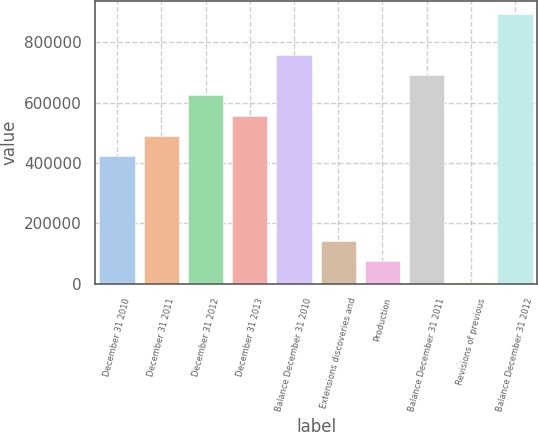<chart> <loc_0><loc_0><loc_500><loc_500><bar_chart><fcel>December 31 2010<fcel>December 31 2011<fcel>December 31 2012<fcel>December 31 2013<fcel>Balance December 31 2010<fcel>Extensions discoveries and<fcel>Production<fcel>Balance December 31 2011<fcel>Revisions of previous<fcel>Balance December 31 2012<nl><fcel>422737<fcel>489780<fcel>623866<fcel>556823<fcel>757952<fcel>141560<fcel>74517.1<fcel>690909<fcel>7474<fcel>892039<nl></chart> 